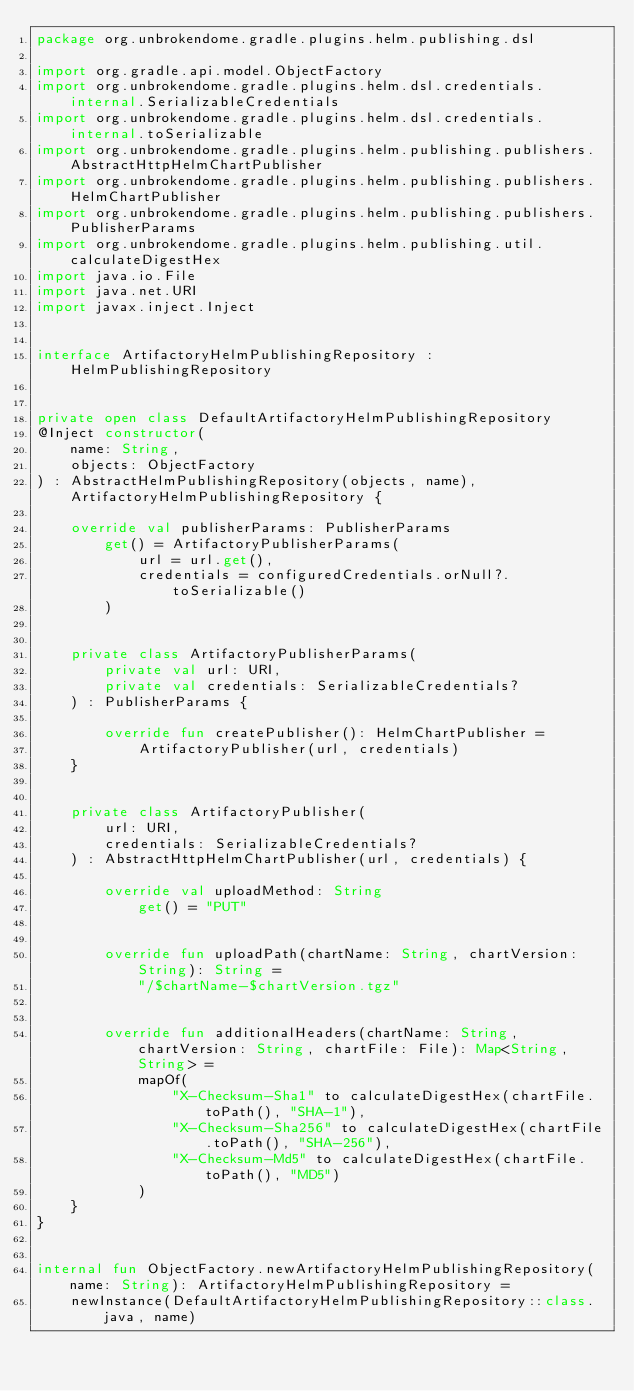<code> <loc_0><loc_0><loc_500><loc_500><_Kotlin_>package org.unbrokendome.gradle.plugins.helm.publishing.dsl

import org.gradle.api.model.ObjectFactory
import org.unbrokendome.gradle.plugins.helm.dsl.credentials.internal.SerializableCredentials
import org.unbrokendome.gradle.plugins.helm.dsl.credentials.internal.toSerializable
import org.unbrokendome.gradle.plugins.helm.publishing.publishers.AbstractHttpHelmChartPublisher
import org.unbrokendome.gradle.plugins.helm.publishing.publishers.HelmChartPublisher
import org.unbrokendome.gradle.plugins.helm.publishing.publishers.PublisherParams
import org.unbrokendome.gradle.plugins.helm.publishing.util.calculateDigestHex
import java.io.File
import java.net.URI
import javax.inject.Inject


interface ArtifactoryHelmPublishingRepository : HelmPublishingRepository


private open class DefaultArtifactoryHelmPublishingRepository
@Inject constructor(
    name: String,
    objects: ObjectFactory
) : AbstractHelmPublishingRepository(objects, name), ArtifactoryHelmPublishingRepository {

    override val publisherParams: PublisherParams
        get() = ArtifactoryPublisherParams(
            url = url.get(),
            credentials = configuredCredentials.orNull?.toSerializable()
        )


    private class ArtifactoryPublisherParams(
        private val url: URI,
        private val credentials: SerializableCredentials?
    ) : PublisherParams {

        override fun createPublisher(): HelmChartPublisher =
            ArtifactoryPublisher(url, credentials)
    }


    private class ArtifactoryPublisher(
        url: URI,
        credentials: SerializableCredentials?
    ) : AbstractHttpHelmChartPublisher(url, credentials) {

        override val uploadMethod: String
            get() = "PUT"


        override fun uploadPath(chartName: String, chartVersion: String): String =
            "/$chartName-$chartVersion.tgz"


        override fun additionalHeaders(chartName: String, chartVersion: String, chartFile: File): Map<String, String> =
            mapOf(
                "X-Checksum-Sha1" to calculateDigestHex(chartFile.toPath(), "SHA-1"),
                "X-Checksum-Sha256" to calculateDigestHex(chartFile.toPath(), "SHA-256"),
                "X-Checksum-Md5" to calculateDigestHex(chartFile.toPath(), "MD5")
            )
    }
}


internal fun ObjectFactory.newArtifactoryHelmPublishingRepository(name: String): ArtifactoryHelmPublishingRepository =
    newInstance(DefaultArtifactoryHelmPublishingRepository::class.java, name)
</code> 